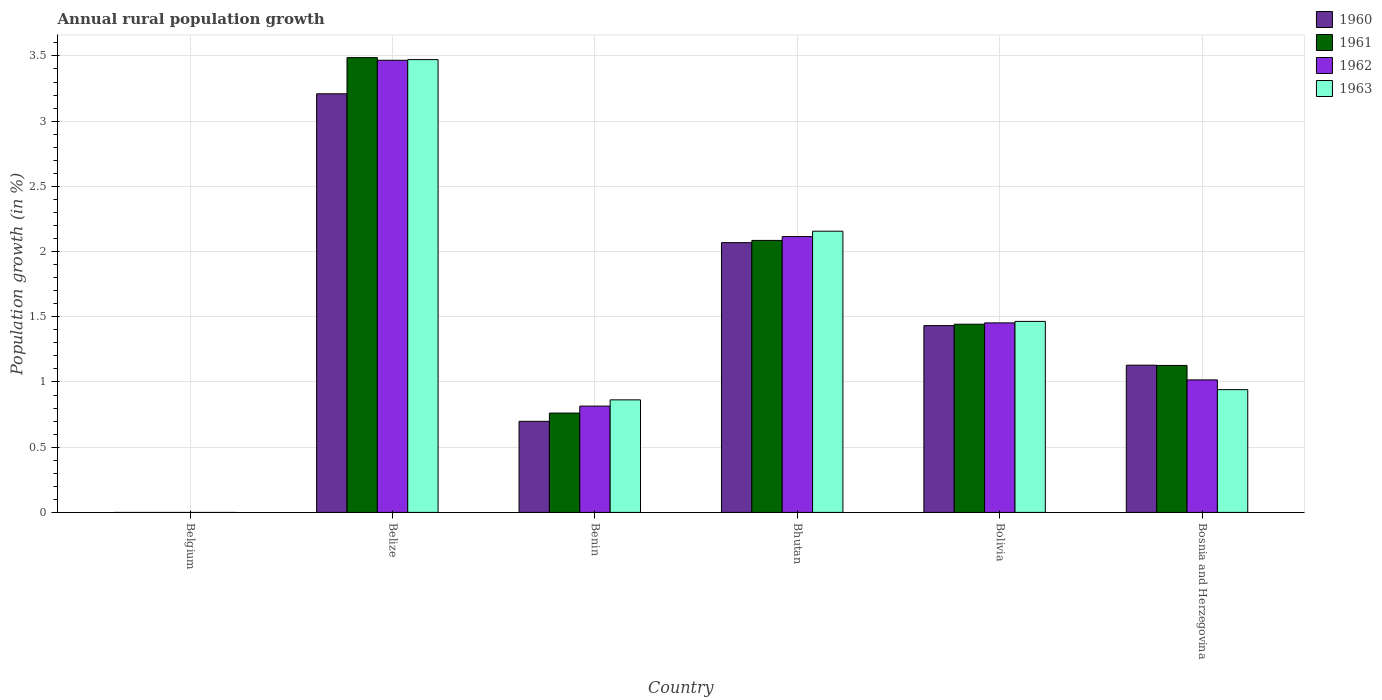How many different coloured bars are there?
Provide a succinct answer. 4. Are the number of bars per tick equal to the number of legend labels?
Keep it short and to the point. No. What is the percentage of rural population growth in 1960 in Bhutan?
Your response must be concise. 2.07. Across all countries, what is the maximum percentage of rural population growth in 1960?
Your answer should be compact. 3.21. Across all countries, what is the minimum percentage of rural population growth in 1961?
Offer a very short reply. 0. In which country was the percentage of rural population growth in 1962 maximum?
Offer a terse response. Belize. What is the total percentage of rural population growth in 1961 in the graph?
Make the answer very short. 8.9. What is the difference between the percentage of rural population growth in 1963 in Belize and that in Benin?
Offer a terse response. 2.61. What is the difference between the percentage of rural population growth in 1962 in Belgium and the percentage of rural population growth in 1960 in Bolivia?
Give a very brief answer. -1.43. What is the average percentage of rural population growth in 1960 per country?
Make the answer very short. 1.42. What is the difference between the percentage of rural population growth of/in 1961 and percentage of rural population growth of/in 1962 in Bhutan?
Make the answer very short. -0.03. What is the ratio of the percentage of rural population growth in 1961 in Belize to that in Benin?
Give a very brief answer. 4.58. Is the percentage of rural population growth in 1960 in Belize less than that in Bolivia?
Ensure brevity in your answer.  No. What is the difference between the highest and the second highest percentage of rural population growth in 1963?
Provide a succinct answer. -0.69. What is the difference between the highest and the lowest percentage of rural population growth in 1960?
Give a very brief answer. 3.21. In how many countries, is the percentage of rural population growth in 1960 greater than the average percentage of rural population growth in 1960 taken over all countries?
Ensure brevity in your answer.  3. Is it the case that in every country, the sum of the percentage of rural population growth in 1963 and percentage of rural population growth in 1962 is greater than the sum of percentage of rural population growth in 1961 and percentage of rural population growth in 1960?
Your answer should be very brief. No. How many bars are there?
Give a very brief answer. 20. Are all the bars in the graph horizontal?
Give a very brief answer. No. Does the graph contain grids?
Your answer should be compact. Yes. How are the legend labels stacked?
Give a very brief answer. Vertical. What is the title of the graph?
Provide a succinct answer. Annual rural population growth. Does "2000" appear as one of the legend labels in the graph?
Keep it short and to the point. No. What is the label or title of the Y-axis?
Ensure brevity in your answer.  Population growth (in %). What is the Population growth (in %) in 1961 in Belgium?
Your answer should be very brief. 0. What is the Population growth (in %) of 1962 in Belgium?
Your answer should be compact. 0. What is the Population growth (in %) in 1963 in Belgium?
Your response must be concise. 0. What is the Population growth (in %) of 1960 in Belize?
Your answer should be very brief. 3.21. What is the Population growth (in %) of 1961 in Belize?
Offer a terse response. 3.49. What is the Population growth (in %) in 1962 in Belize?
Provide a succinct answer. 3.47. What is the Population growth (in %) in 1963 in Belize?
Ensure brevity in your answer.  3.47. What is the Population growth (in %) of 1960 in Benin?
Your answer should be very brief. 0.7. What is the Population growth (in %) in 1961 in Benin?
Give a very brief answer. 0.76. What is the Population growth (in %) in 1962 in Benin?
Make the answer very short. 0.81. What is the Population growth (in %) in 1963 in Benin?
Ensure brevity in your answer.  0.86. What is the Population growth (in %) of 1960 in Bhutan?
Provide a succinct answer. 2.07. What is the Population growth (in %) of 1961 in Bhutan?
Offer a very short reply. 2.09. What is the Population growth (in %) in 1962 in Bhutan?
Your answer should be very brief. 2.11. What is the Population growth (in %) of 1963 in Bhutan?
Your response must be concise. 2.16. What is the Population growth (in %) of 1960 in Bolivia?
Your response must be concise. 1.43. What is the Population growth (in %) in 1961 in Bolivia?
Make the answer very short. 1.44. What is the Population growth (in %) in 1962 in Bolivia?
Your answer should be compact. 1.45. What is the Population growth (in %) in 1963 in Bolivia?
Your answer should be compact. 1.46. What is the Population growth (in %) in 1960 in Bosnia and Herzegovina?
Provide a short and direct response. 1.13. What is the Population growth (in %) in 1961 in Bosnia and Herzegovina?
Make the answer very short. 1.13. What is the Population growth (in %) in 1962 in Bosnia and Herzegovina?
Keep it short and to the point. 1.02. What is the Population growth (in %) of 1963 in Bosnia and Herzegovina?
Your answer should be compact. 0.94. Across all countries, what is the maximum Population growth (in %) of 1960?
Your answer should be compact. 3.21. Across all countries, what is the maximum Population growth (in %) of 1961?
Your response must be concise. 3.49. Across all countries, what is the maximum Population growth (in %) of 1962?
Your answer should be compact. 3.47. Across all countries, what is the maximum Population growth (in %) in 1963?
Offer a very short reply. 3.47. Across all countries, what is the minimum Population growth (in %) in 1961?
Offer a terse response. 0. What is the total Population growth (in %) in 1960 in the graph?
Make the answer very short. 8.54. What is the total Population growth (in %) in 1961 in the graph?
Offer a terse response. 8.9. What is the total Population growth (in %) of 1962 in the graph?
Your answer should be very brief. 8.87. What is the total Population growth (in %) in 1963 in the graph?
Give a very brief answer. 8.9. What is the difference between the Population growth (in %) in 1960 in Belize and that in Benin?
Offer a terse response. 2.51. What is the difference between the Population growth (in %) of 1961 in Belize and that in Benin?
Offer a very short reply. 2.73. What is the difference between the Population growth (in %) in 1962 in Belize and that in Benin?
Offer a very short reply. 2.65. What is the difference between the Population growth (in %) in 1963 in Belize and that in Benin?
Provide a succinct answer. 2.61. What is the difference between the Population growth (in %) of 1960 in Belize and that in Bhutan?
Ensure brevity in your answer.  1.14. What is the difference between the Population growth (in %) in 1961 in Belize and that in Bhutan?
Offer a very short reply. 1.4. What is the difference between the Population growth (in %) in 1962 in Belize and that in Bhutan?
Provide a succinct answer. 1.35. What is the difference between the Population growth (in %) in 1963 in Belize and that in Bhutan?
Provide a short and direct response. 1.32. What is the difference between the Population growth (in %) in 1960 in Belize and that in Bolivia?
Offer a terse response. 1.78. What is the difference between the Population growth (in %) of 1961 in Belize and that in Bolivia?
Your answer should be very brief. 2.04. What is the difference between the Population growth (in %) of 1962 in Belize and that in Bolivia?
Provide a short and direct response. 2.01. What is the difference between the Population growth (in %) in 1963 in Belize and that in Bolivia?
Your answer should be compact. 2.01. What is the difference between the Population growth (in %) in 1960 in Belize and that in Bosnia and Herzegovina?
Keep it short and to the point. 2.08. What is the difference between the Population growth (in %) in 1961 in Belize and that in Bosnia and Herzegovina?
Your answer should be compact. 2.36. What is the difference between the Population growth (in %) in 1962 in Belize and that in Bosnia and Herzegovina?
Give a very brief answer. 2.45. What is the difference between the Population growth (in %) in 1963 in Belize and that in Bosnia and Herzegovina?
Keep it short and to the point. 2.53. What is the difference between the Population growth (in %) in 1960 in Benin and that in Bhutan?
Ensure brevity in your answer.  -1.37. What is the difference between the Population growth (in %) of 1961 in Benin and that in Bhutan?
Provide a short and direct response. -1.32. What is the difference between the Population growth (in %) of 1962 in Benin and that in Bhutan?
Provide a short and direct response. -1.3. What is the difference between the Population growth (in %) in 1963 in Benin and that in Bhutan?
Offer a very short reply. -1.29. What is the difference between the Population growth (in %) of 1960 in Benin and that in Bolivia?
Offer a very short reply. -0.73. What is the difference between the Population growth (in %) in 1961 in Benin and that in Bolivia?
Offer a very short reply. -0.68. What is the difference between the Population growth (in %) of 1962 in Benin and that in Bolivia?
Your answer should be compact. -0.64. What is the difference between the Population growth (in %) of 1963 in Benin and that in Bolivia?
Offer a terse response. -0.6. What is the difference between the Population growth (in %) of 1960 in Benin and that in Bosnia and Herzegovina?
Ensure brevity in your answer.  -0.43. What is the difference between the Population growth (in %) in 1961 in Benin and that in Bosnia and Herzegovina?
Ensure brevity in your answer.  -0.37. What is the difference between the Population growth (in %) of 1962 in Benin and that in Bosnia and Herzegovina?
Make the answer very short. -0.2. What is the difference between the Population growth (in %) in 1963 in Benin and that in Bosnia and Herzegovina?
Make the answer very short. -0.08. What is the difference between the Population growth (in %) of 1960 in Bhutan and that in Bolivia?
Your answer should be compact. 0.64. What is the difference between the Population growth (in %) in 1961 in Bhutan and that in Bolivia?
Keep it short and to the point. 0.64. What is the difference between the Population growth (in %) in 1962 in Bhutan and that in Bolivia?
Give a very brief answer. 0.66. What is the difference between the Population growth (in %) in 1963 in Bhutan and that in Bolivia?
Offer a terse response. 0.69. What is the difference between the Population growth (in %) in 1960 in Bhutan and that in Bosnia and Herzegovina?
Ensure brevity in your answer.  0.94. What is the difference between the Population growth (in %) in 1961 in Bhutan and that in Bosnia and Herzegovina?
Make the answer very short. 0.96. What is the difference between the Population growth (in %) of 1962 in Bhutan and that in Bosnia and Herzegovina?
Provide a short and direct response. 1.1. What is the difference between the Population growth (in %) in 1963 in Bhutan and that in Bosnia and Herzegovina?
Provide a succinct answer. 1.21. What is the difference between the Population growth (in %) of 1960 in Bolivia and that in Bosnia and Herzegovina?
Give a very brief answer. 0.3. What is the difference between the Population growth (in %) of 1961 in Bolivia and that in Bosnia and Herzegovina?
Keep it short and to the point. 0.32. What is the difference between the Population growth (in %) of 1962 in Bolivia and that in Bosnia and Herzegovina?
Give a very brief answer. 0.44. What is the difference between the Population growth (in %) in 1963 in Bolivia and that in Bosnia and Herzegovina?
Your answer should be compact. 0.52. What is the difference between the Population growth (in %) of 1960 in Belize and the Population growth (in %) of 1961 in Benin?
Keep it short and to the point. 2.45. What is the difference between the Population growth (in %) in 1960 in Belize and the Population growth (in %) in 1962 in Benin?
Your answer should be compact. 2.39. What is the difference between the Population growth (in %) in 1960 in Belize and the Population growth (in %) in 1963 in Benin?
Provide a succinct answer. 2.35. What is the difference between the Population growth (in %) of 1961 in Belize and the Population growth (in %) of 1962 in Benin?
Keep it short and to the point. 2.67. What is the difference between the Population growth (in %) of 1961 in Belize and the Population growth (in %) of 1963 in Benin?
Your answer should be compact. 2.62. What is the difference between the Population growth (in %) of 1962 in Belize and the Population growth (in %) of 1963 in Benin?
Offer a terse response. 2.6. What is the difference between the Population growth (in %) in 1960 in Belize and the Population growth (in %) in 1961 in Bhutan?
Provide a succinct answer. 1.12. What is the difference between the Population growth (in %) in 1960 in Belize and the Population growth (in %) in 1962 in Bhutan?
Keep it short and to the point. 1.09. What is the difference between the Population growth (in %) of 1960 in Belize and the Population growth (in %) of 1963 in Bhutan?
Keep it short and to the point. 1.05. What is the difference between the Population growth (in %) in 1961 in Belize and the Population growth (in %) in 1962 in Bhutan?
Ensure brevity in your answer.  1.37. What is the difference between the Population growth (in %) in 1961 in Belize and the Population growth (in %) in 1963 in Bhutan?
Keep it short and to the point. 1.33. What is the difference between the Population growth (in %) of 1962 in Belize and the Population growth (in %) of 1963 in Bhutan?
Make the answer very short. 1.31. What is the difference between the Population growth (in %) in 1960 in Belize and the Population growth (in %) in 1961 in Bolivia?
Provide a short and direct response. 1.77. What is the difference between the Population growth (in %) of 1960 in Belize and the Population growth (in %) of 1962 in Bolivia?
Your answer should be very brief. 1.76. What is the difference between the Population growth (in %) in 1960 in Belize and the Population growth (in %) in 1963 in Bolivia?
Provide a succinct answer. 1.75. What is the difference between the Population growth (in %) in 1961 in Belize and the Population growth (in %) in 1962 in Bolivia?
Your response must be concise. 2.03. What is the difference between the Population growth (in %) in 1961 in Belize and the Population growth (in %) in 1963 in Bolivia?
Make the answer very short. 2.02. What is the difference between the Population growth (in %) of 1962 in Belize and the Population growth (in %) of 1963 in Bolivia?
Offer a very short reply. 2. What is the difference between the Population growth (in %) of 1960 in Belize and the Population growth (in %) of 1961 in Bosnia and Herzegovina?
Make the answer very short. 2.08. What is the difference between the Population growth (in %) in 1960 in Belize and the Population growth (in %) in 1962 in Bosnia and Herzegovina?
Provide a short and direct response. 2.19. What is the difference between the Population growth (in %) of 1960 in Belize and the Population growth (in %) of 1963 in Bosnia and Herzegovina?
Offer a terse response. 2.27. What is the difference between the Population growth (in %) in 1961 in Belize and the Population growth (in %) in 1962 in Bosnia and Herzegovina?
Provide a short and direct response. 2.47. What is the difference between the Population growth (in %) in 1961 in Belize and the Population growth (in %) in 1963 in Bosnia and Herzegovina?
Your answer should be compact. 2.55. What is the difference between the Population growth (in %) of 1962 in Belize and the Population growth (in %) of 1963 in Bosnia and Herzegovina?
Your answer should be compact. 2.53. What is the difference between the Population growth (in %) in 1960 in Benin and the Population growth (in %) in 1961 in Bhutan?
Make the answer very short. -1.39. What is the difference between the Population growth (in %) of 1960 in Benin and the Population growth (in %) of 1962 in Bhutan?
Your response must be concise. -1.42. What is the difference between the Population growth (in %) in 1960 in Benin and the Population growth (in %) in 1963 in Bhutan?
Offer a very short reply. -1.46. What is the difference between the Population growth (in %) in 1961 in Benin and the Population growth (in %) in 1962 in Bhutan?
Keep it short and to the point. -1.35. What is the difference between the Population growth (in %) of 1961 in Benin and the Population growth (in %) of 1963 in Bhutan?
Offer a terse response. -1.39. What is the difference between the Population growth (in %) in 1962 in Benin and the Population growth (in %) in 1963 in Bhutan?
Provide a succinct answer. -1.34. What is the difference between the Population growth (in %) of 1960 in Benin and the Population growth (in %) of 1961 in Bolivia?
Offer a terse response. -0.74. What is the difference between the Population growth (in %) in 1960 in Benin and the Population growth (in %) in 1962 in Bolivia?
Provide a succinct answer. -0.75. What is the difference between the Population growth (in %) in 1960 in Benin and the Population growth (in %) in 1963 in Bolivia?
Provide a short and direct response. -0.77. What is the difference between the Population growth (in %) of 1961 in Benin and the Population growth (in %) of 1962 in Bolivia?
Provide a short and direct response. -0.69. What is the difference between the Population growth (in %) in 1961 in Benin and the Population growth (in %) in 1963 in Bolivia?
Ensure brevity in your answer.  -0.7. What is the difference between the Population growth (in %) in 1962 in Benin and the Population growth (in %) in 1963 in Bolivia?
Offer a terse response. -0.65. What is the difference between the Population growth (in %) of 1960 in Benin and the Population growth (in %) of 1961 in Bosnia and Herzegovina?
Your answer should be compact. -0.43. What is the difference between the Population growth (in %) in 1960 in Benin and the Population growth (in %) in 1962 in Bosnia and Herzegovina?
Provide a succinct answer. -0.32. What is the difference between the Population growth (in %) in 1960 in Benin and the Population growth (in %) in 1963 in Bosnia and Herzegovina?
Make the answer very short. -0.24. What is the difference between the Population growth (in %) in 1961 in Benin and the Population growth (in %) in 1962 in Bosnia and Herzegovina?
Provide a succinct answer. -0.25. What is the difference between the Population growth (in %) of 1961 in Benin and the Population growth (in %) of 1963 in Bosnia and Herzegovina?
Keep it short and to the point. -0.18. What is the difference between the Population growth (in %) in 1962 in Benin and the Population growth (in %) in 1963 in Bosnia and Herzegovina?
Keep it short and to the point. -0.13. What is the difference between the Population growth (in %) in 1960 in Bhutan and the Population growth (in %) in 1961 in Bolivia?
Your answer should be compact. 0.63. What is the difference between the Population growth (in %) in 1960 in Bhutan and the Population growth (in %) in 1962 in Bolivia?
Offer a terse response. 0.62. What is the difference between the Population growth (in %) in 1960 in Bhutan and the Population growth (in %) in 1963 in Bolivia?
Your answer should be compact. 0.6. What is the difference between the Population growth (in %) in 1961 in Bhutan and the Population growth (in %) in 1962 in Bolivia?
Your answer should be very brief. 0.63. What is the difference between the Population growth (in %) of 1961 in Bhutan and the Population growth (in %) of 1963 in Bolivia?
Your answer should be compact. 0.62. What is the difference between the Population growth (in %) in 1962 in Bhutan and the Population growth (in %) in 1963 in Bolivia?
Make the answer very short. 0.65. What is the difference between the Population growth (in %) in 1960 in Bhutan and the Population growth (in %) in 1961 in Bosnia and Herzegovina?
Offer a very short reply. 0.94. What is the difference between the Population growth (in %) in 1960 in Bhutan and the Population growth (in %) in 1962 in Bosnia and Herzegovina?
Offer a very short reply. 1.05. What is the difference between the Population growth (in %) of 1960 in Bhutan and the Population growth (in %) of 1963 in Bosnia and Herzegovina?
Provide a succinct answer. 1.13. What is the difference between the Population growth (in %) in 1961 in Bhutan and the Population growth (in %) in 1962 in Bosnia and Herzegovina?
Provide a short and direct response. 1.07. What is the difference between the Population growth (in %) of 1961 in Bhutan and the Population growth (in %) of 1963 in Bosnia and Herzegovina?
Give a very brief answer. 1.14. What is the difference between the Population growth (in %) of 1962 in Bhutan and the Population growth (in %) of 1963 in Bosnia and Herzegovina?
Ensure brevity in your answer.  1.17. What is the difference between the Population growth (in %) in 1960 in Bolivia and the Population growth (in %) in 1961 in Bosnia and Herzegovina?
Provide a short and direct response. 0.31. What is the difference between the Population growth (in %) in 1960 in Bolivia and the Population growth (in %) in 1962 in Bosnia and Herzegovina?
Offer a terse response. 0.42. What is the difference between the Population growth (in %) of 1960 in Bolivia and the Population growth (in %) of 1963 in Bosnia and Herzegovina?
Give a very brief answer. 0.49. What is the difference between the Population growth (in %) of 1961 in Bolivia and the Population growth (in %) of 1962 in Bosnia and Herzegovina?
Offer a very short reply. 0.43. What is the difference between the Population growth (in %) in 1961 in Bolivia and the Population growth (in %) in 1963 in Bosnia and Herzegovina?
Ensure brevity in your answer.  0.5. What is the difference between the Population growth (in %) of 1962 in Bolivia and the Population growth (in %) of 1963 in Bosnia and Herzegovina?
Provide a succinct answer. 0.51. What is the average Population growth (in %) in 1960 per country?
Your answer should be compact. 1.42. What is the average Population growth (in %) of 1961 per country?
Ensure brevity in your answer.  1.48. What is the average Population growth (in %) in 1962 per country?
Offer a very short reply. 1.48. What is the average Population growth (in %) of 1963 per country?
Keep it short and to the point. 1.48. What is the difference between the Population growth (in %) in 1960 and Population growth (in %) in 1961 in Belize?
Your response must be concise. -0.28. What is the difference between the Population growth (in %) of 1960 and Population growth (in %) of 1962 in Belize?
Your answer should be compact. -0.26. What is the difference between the Population growth (in %) of 1960 and Population growth (in %) of 1963 in Belize?
Give a very brief answer. -0.26. What is the difference between the Population growth (in %) in 1961 and Population growth (in %) in 1962 in Belize?
Make the answer very short. 0.02. What is the difference between the Population growth (in %) of 1961 and Population growth (in %) of 1963 in Belize?
Offer a terse response. 0.02. What is the difference between the Population growth (in %) in 1962 and Population growth (in %) in 1963 in Belize?
Ensure brevity in your answer.  -0.01. What is the difference between the Population growth (in %) in 1960 and Population growth (in %) in 1961 in Benin?
Give a very brief answer. -0.06. What is the difference between the Population growth (in %) in 1960 and Population growth (in %) in 1962 in Benin?
Give a very brief answer. -0.12. What is the difference between the Population growth (in %) in 1960 and Population growth (in %) in 1963 in Benin?
Offer a terse response. -0.16. What is the difference between the Population growth (in %) in 1961 and Population growth (in %) in 1962 in Benin?
Offer a very short reply. -0.05. What is the difference between the Population growth (in %) in 1961 and Population growth (in %) in 1963 in Benin?
Your answer should be compact. -0.1. What is the difference between the Population growth (in %) in 1962 and Population growth (in %) in 1963 in Benin?
Keep it short and to the point. -0.05. What is the difference between the Population growth (in %) in 1960 and Population growth (in %) in 1961 in Bhutan?
Provide a succinct answer. -0.02. What is the difference between the Population growth (in %) of 1960 and Population growth (in %) of 1962 in Bhutan?
Provide a succinct answer. -0.05. What is the difference between the Population growth (in %) of 1960 and Population growth (in %) of 1963 in Bhutan?
Offer a very short reply. -0.09. What is the difference between the Population growth (in %) of 1961 and Population growth (in %) of 1962 in Bhutan?
Your response must be concise. -0.03. What is the difference between the Population growth (in %) in 1961 and Population growth (in %) in 1963 in Bhutan?
Make the answer very short. -0.07. What is the difference between the Population growth (in %) of 1962 and Population growth (in %) of 1963 in Bhutan?
Offer a very short reply. -0.04. What is the difference between the Population growth (in %) in 1960 and Population growth (in %) in 1961 in Bolivia?
Provide a succinct answer. -0.01. What is the difference between the Population growth (in %) of 1960 and Population growth (in %) of 1962 in Bolivia?
Your answer should be very brief. -0.02. What is the difference between the Population growth (in %) of 1960 and Population growth (in %) of 1963 in Bolivia?
Keep it short and to the point. -0.03. What is the difference between the Population growth (in %) of 1961 and Population growth (in %) of 1962 in Bolivia?
Provide a short and direct response. -0.01. What is the difference between the Population growth (in %) in 1961 and Population growth (in %) in 1963 in Bolivia?
Your answer should be compact. -0.02. What is the difference between the Population growth (in %) in 1962 and Population growth (in %) in 1963 in Bolivia?
Provide a succinct answer. -0.01. What is the difference between the Population growth (in %) in 1960 and Population growth (in %) in 1961 in Bosnia and Herzegovina?
Offer a very short reply. 0. What is the difference between the Population growth (in %) in 1960 and Population growth (in %) in 1962 in Bosnia and Herzegovina?
Your answer should be very brief. 0.11. What is the difference between the Population growth (in %) of 1960 and Population growth (in %) of 1963 in Bosnia and Herzegovina?
Your answer should be compact. 0.19. What is the difference between the Population growth (in %) in 1961 and Population growth (in %) in 1962 in Bosnia and Herzegovina?
Offer a very short reply. 0.11. What is the difference between the Population growth (in %) in 1961 and Population growth (in %) in 1963 in Bosnia and Herzegovina?
Provide a succinct answer. 0.19. What is the difference between the Population growth (in %) in 1962 and Population growth (in %) in 1963 in Bosnia and Herzegovina?
Make the answer very short. 0.07. What is the ratio of the Population growth (in %) of 1960 in Belize to that in Benin?
Provide a short and direct response. 4.6. What is the ratio of the Population growth (in %) of 1961 in Belize to that in Benin?
Your response must be concise. 4.58. What is the ratio of the Population growth (in %) of 1962 in Belize to that in Benin?
Provide a succinct answer. 4.25. What is the ratio of the Population growth (in %) in 1963 in Belize to that in Benin?
Ensure brevity in your answer.  4.02. What is the ratio of the Population growth (in %) of 1960 in Belize to that in Bhutan?
Make the answer very short. 1.55. What is the ratio of the Population growth (in %) in 1961 in Belize to that in Bhutan?
Keep it short and to the point. 1.67. What is the ratio of the Population growth (in %) of 1962 in Belize to that in Bhutan?
Your response must be concise. 1.64. What is the ratio of the Population growth (in %) in 1963 in Belize to that in Bhutan?
Provide a short and direct response. 1.61. What is the ratio of the Population growth (in %) in 1960 in Belize to that in Bolivia?
Offer a terse response. 2.24. What is the ratio of the Population growth (in %) in 1961 in Belize to that in Bolivia?
Your response must be concise. 2.42. What is the ratio of the Population growth (in %) in 1962 in Belize to that in Bolivia?
Provide a succinct answer. 2.39. What is the ratio of the Population growth (in %) in 1963 in Belize to that in Bolivia?
Provide a short and direct response. 2.37. What is the ratio of the Population growth (in %) in 1960 in Belize to that in Bosnia and Herzegovina?
Keep it short and to the point. 2.84. What is the ratio of the Population growth (in %) in 1961 in Belize to that in Bosnia and Herzegovina?
Make the answer very short. 3.09. What is the ratio of the Population growth (in %) in 1962 in Belize to that in Bosnia and Herzegovina?
Give a very brief answer. 3.41. What is the ratio of the Population growth (in %) in 1963 in Belize to that in Bosnia and Herzegovina?
Offer a terse response. 3.69. What is the ratio of the Population growth (in %) in 1960 in Benin to that in Bhutan?
Offer a terse response. 0.34. What is the ratio of the Population growth (in %) in 1961 in Benin to that in Bhutan?
Offer a terse response. 0.37. What is the ratio of the Population growth (in %) in 1962 in Benin to that in Bhutan?
Make the answer very short. 0.39. What is the ratio of the Population growth (in %) in 1963 in Benin to that in Bhutan?
Ensure brevity in your answer.  0.4. What is the ratio of the Population growth (in %) of 1960 in Benin to that in Bolivia?
Your response must be concise. 0.49. What is the ratio of the Population growth (in %) of 1961 in Benin to that in Bolivia?
Your response must be concise. 0.53. What is the ratio of the Population growth (in %) in 1962 in Benin to that in Bolivia?
Your answer should be very brief. 0.56. What is the ratio of the Population growth (in %) of 1963 in Benin to that in Bolivia?
Keep it short and to the point. 0.59. What is the ratio of the Population growth (in %) of 1960 in Benin to that in Bosnia and Herzegovina?
Ensure brevity in your answer.  0.62. What is the ratio of the Population growth (in %) in 1961 in Benin to that in Bosnia and Herzegovina?
Give a very brief answer. 0.68. What is the ratio of the Population growth (in %) in 1962 in Benin to that in Bosnia and Herzegovina?
Make the answer very short. 0.8. What is the ratio of the Population growth (in %) of 1960 in Bhutan to that in Bolivia?
Provide a short and direct response. 1.44. What is the ratio of the Population growth (in %) of 1961 in Bhutan to that in Bolivia?
Your answer should be very brief. 1.45. What is the ratio of the Population growth (in %) of 1962 in Bhutan to that in Bolivia?
Give a very brief answer. 1.46. What is the ratio of the Population growth (in %) in 1963 in Bhutan to that in Bolivia?
Keep it short and to the point. 1.47. What is the ratio of the Population growth (in %) in 1960 in Bhutan to that in Bosnia and Herzegovina?
Provide a short and direct response. 1.83. What is the ratio of the Population growth (in %) in 1961 in Bhutan to that in Bosnia and Herzegovina?
Ensure brevity in your answer.  1.85. What is the ratio of the Population growth (in %) of 1962 in Bhutan to that in Bosnia and Herzegovina?
Offer a very short reply. 2.08. What is the ratio of the Population growth (in %) of 1963 in Bhutan to that in Bosnia and Herzegovina?
Provide a short and direct response. 2.29. What is the ratio of the Population growth (in %) of 1960 in Bolivia to that in Bosnia and Herzegovina?
Your answer should be compact. 1.27. What is the ratio of the Population growth (in %) in 1961 in Bolivia to that in Bosnia and Herzegovina?
Provide a short and direct response. 1.28. What is the ratio of the Population growth (in %) of 1962 in Bolivia to that in Bosnia and Herzegovina?
Offer a terse response. 1.43. What is the ratio of the Population growth (in %) in 1963 in Bolivia to that in Bosnia and Herzegovina?
Ensure brevity in your answer.  1.56. What is the difference between the highest and the second highest Population growth (in %) in 1960?
Make the answer very short. 1.14. What is the difference between the highest and the second highest Population growth (in %) of 1961?
Make the answer very short. 1.4. What is the difference between the highest and the second highest Population growth (in %) in 1962?
Your answer should be very brief. 1.35. What is the difference between the highest and the second highest Population growth (in %) in 1963?
Ensure brevity in your answer.  1.32. What is the difference between the highest and the lowest Population growth (in %) of 1960?
Offer a very short reply. 3.21. What is the difference between the highest and the lowest Population growth (in %) of 1961?
Your answer should be very brief. 3.49. What is the difference between the highest and the lowest Population growth (in %) of 1962?
Your response must be concise. 3.47. What is the difference between the highest and the lowest Population growth (in %) in 1963?
Keep it short and to the point. 3.47. 